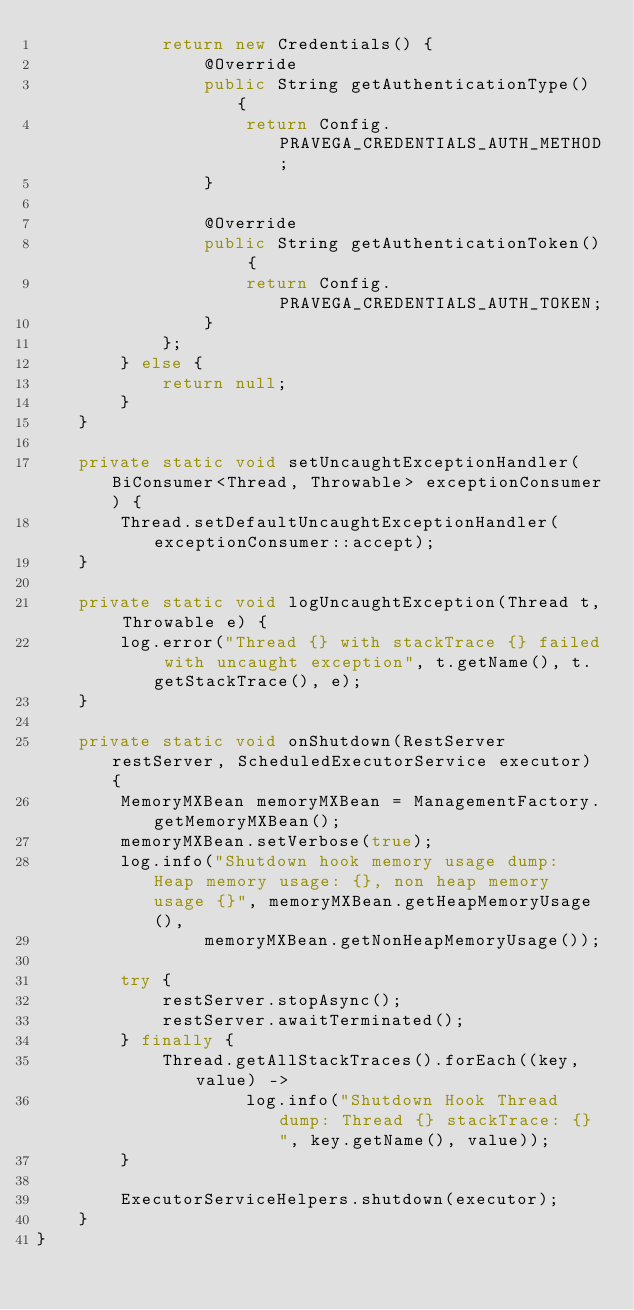Convert code to text. <code><loc_0><loc_0><loc_500><loc_500><_Java_>            return new Credentials() {
                @Override
                public String getAuthenticationType() {
                    return Config.PRAVEGA_CREDENTIALS_AUTH_METHOD;
                }

                @Override
                public String getAuthenticationToken() {
                    return Config.PRAVEGA_CREDENTIALS_AUTH_TOKEN;
                }
            };
        } else {
            return null;
        }
    }

    private static void setUncaughtExceptionHandler(BiConsumer<Thread, Throwable> exceptionConsumer) {
        Thread.setDefaultUncaughtExceptionHandler(exceptionConsumer::accept);
    }

    private static void logUncaughtException(Thread t, Throwable e) {
        log.error("Thread {} with stackTrace {} failed with uncaught exception", t.getName(), t.getStackTrace(), e);
    }

    private static void onShutdown(RestServer restServer, ScheduledExecutorService executor) {
        MemoryMXBean memoryMXBean = ManagementFactory.getMemoryMXBean();
        memoryMXBean.setVerbose(true);
        log.info("Shutdown hook memory usage dump: Heap memory usage: {}, non heap memory usage {}", memoryMXBean.getHeapMemoryUsage(),
                memoryMXBean.getNonHeapMemoryUsage());

        try {
            restServer.stopAsync();
            restServer.awaitTerminated();
        } finally {
            Thread.getAllStackTraces().forEach((key, value) ->
                    log.info("Shutdown Hook Thread dump: Thread {} stackTrace: {} ", key.getName(), value));
        }

        ExecutorServiceHelpers.shutdown(executor);
    }
}
</code> 